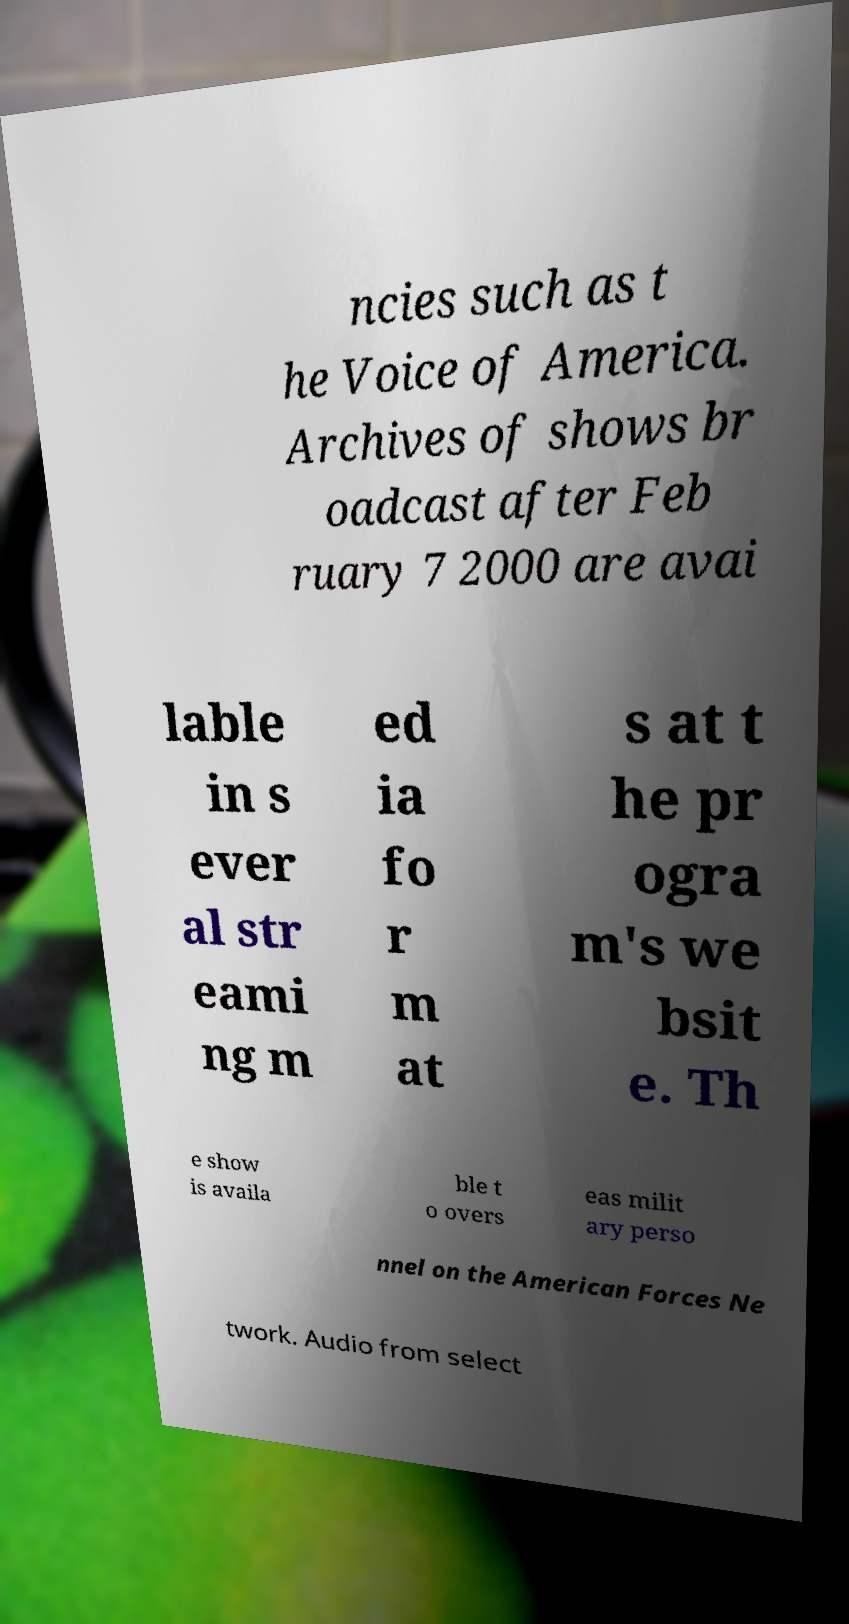Can you accurately transcribe the text from the provided image for me? ncies such as t he Voice of America. Archives of shows br oadcast after Feb ruary 7 2000 are avai lable in s ever al str eami ng m ed ia fo r m at s at t he pr ogra m's we bsit e. Th e show is availa ble t o overs eas milit ary perso nnel on the American Forces Ne twork. Audio from select 